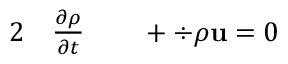Convert formula to latex. <formula><loc_0><loc_0><loc_500><loc_500>\begin{array} { r l r l } { 2 } & \frac { \partial \rho } { \partial t } } & + \div { \rho u } = 0 } \end{array}</formula> 